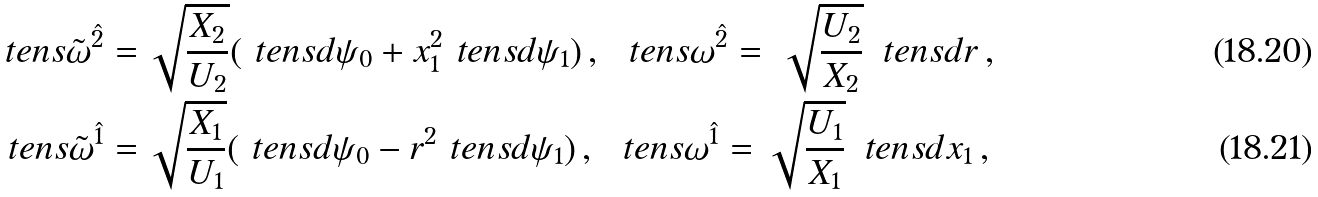Convert formula to latex. <formula><loc_0><loc_0><loc_500><loc_500>\ t e n s { \tilde { \omega } } ^ { \hat { 2 } } = & \, \sqrt { \frac { X _ { 2 } } { U _ { 2 } } } ( \ t e n s { d } \psi _ { 0 } + x _ { 1 } ^ { 2 } \ t e n s { d } \psi _ { 1 } ) \, , \ \ t e n s { \omega } ^ { \hat { 2 } } = \, \sqrt { \frac { U _ { 2 } } { X _ { 2 } } } \, \ t e n s { d } r \, , \\ \ t e n s { \tilde { \omega } } ^ { \hat { 1 } } = & \, \sqrt { \frac { X _ { 1 } } { U _ { 1 } } } ( \ t e n s { d } \psi _ { 0 } - r ^ { 2 } \ t e n s { d } \psi _ { 1 } ) \, , \ \ t e n s { \omega } ^ { \hat { 1 } } = \sqrt { \frac { U _ { 1 } } { X _ { 1 } } } \, \ t e n s { d } x _ { 1 } \, ,</formula> 